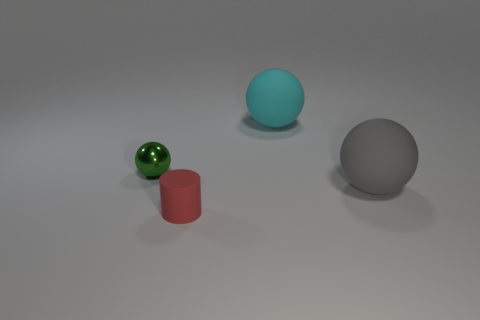Is there any other thing that has the same material as the tiny green ball?
Ensure brevity in your answer.  No. Is the size of the green ball the same as the cyan object?
Provide a short and direct response. No. What size is the rubber thing that is both behind the small red matte thing and on the left side of the big gray ball?
Provide a succinct answer. Large. Are there more small cylinders that are behind the tiny green ball than tiny balls to the right of the small rubber thing?
Make the answer very short. No. There is another metallic object that is the same shape as the cyan object; what color is it?
Make the answer very short. Green. There is a big matte object in front of the cyan thing; is it the same color as the matte cylinder?
Your answer should be compact. No. What number of big balls are there?
Your answer should be very brief. 2. Is the object in front of the gray matte ball made of the same material as the small ball?
Your response must be concise. No. What number of tiny things are behind the big ball that is behind the green metal object in front of the large cyan object?
Give a very brief answer. 0. What size is the shiny ball?
Your answer should be compact. Small. 